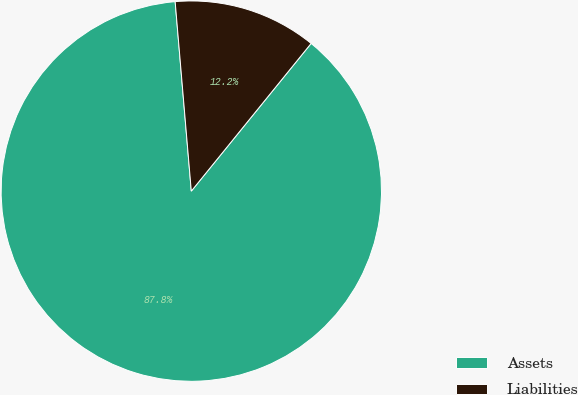Convert chart. <chart><loc_0><loc_0><loc_500><loc_500><pie_chart><fcel>Assets<fcel>Liabilities<nl><fcel>87.8%<fcel>12.2%<nl></chart> 